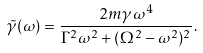<formula> <loc_0><loc_0><loc_500><loc_500>\tilde { \gamma } ( \omega ) = \frac { 2 m \gamma \omega ^ { 4 } } { \Gamma ^ { 2 } \omega ^ { 2 } + ( \Omega ^ { 2 } - \omega ^ { 2 } ) ^ { 2 } } .</formula> 